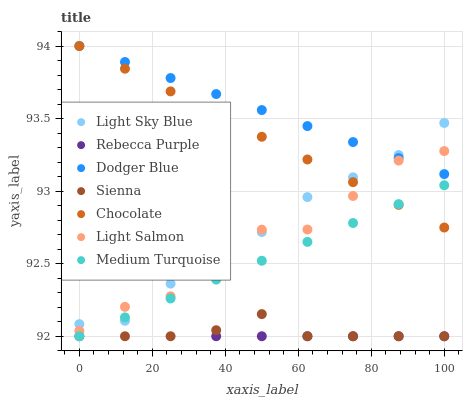Does Sienna have the minimum area under the curve?
Answer yes or no. Yes. Does Dodger Blue have the maximum area under the curve?
Answer yes or no. Yes. Does Chocolate have the minimum area under the curve?
Answer yes or no. No. Does Chocolate have the maximum area under the curve?
Answer yes or no. No. Is Dodger Blue the smoothest?
Answer yes or no. Yes. Is Rebecca Purple the roughest?
Answer yes or no. Yes. Is Chocolate the smoothest?
Answer yes or no. No. Is Chocolate the roughest?
Answer yes or no. No. Does Sienna have the lowest value?
Answer yes or no. Yes. Does Chocolate have the lowest value?
Answer yes or no. No. Does Dodger Blue have the highest value?
Answer yes or no. Yes. Does Sienna have the highest value?
Answer yes or no. No. Is Sienna less than Light Sky Blue?
Answer yes or no. Yes. Is Dodger Blue greater than Rebecca Purple?
Answer yes or no. Yes. Does Chocolate intersect Dodger Blue?
Answer yes or no. Yes. Is Chocolate less than Dodger Blue?
Answer yes or no. No. Is Chocolate greater than Dodger Blue?
Answer yes or no. No. Does Sienna intersect Light Sky Blue?
Answer yes or no. No. 